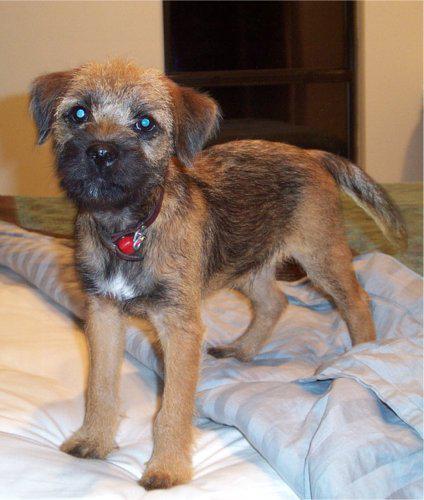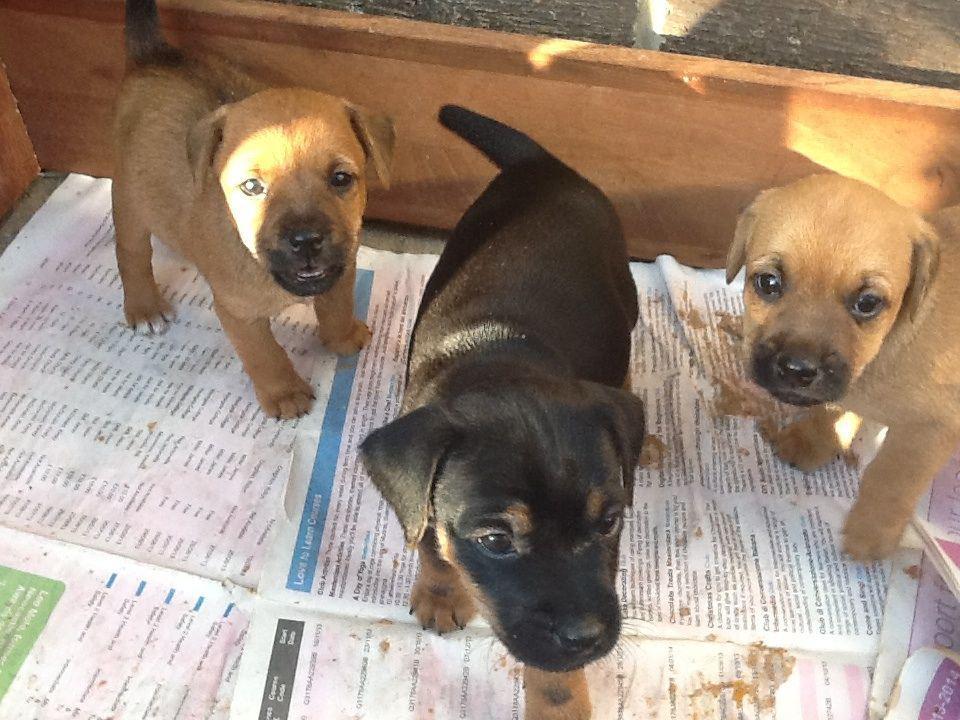The first image is the image on the left, the second image is the image on the right. Given the left and right images, does the statement "The dog in one of the images is being held in a person's hand." hold true? Answer yes or no. No. The first image is the image on the left, the second image is the image on the right. Given the left and right images, does the statement "One image shows a puppy held in a pair of hands, with its front paws draped over a hand." hold true? Answer yes or no. No. 